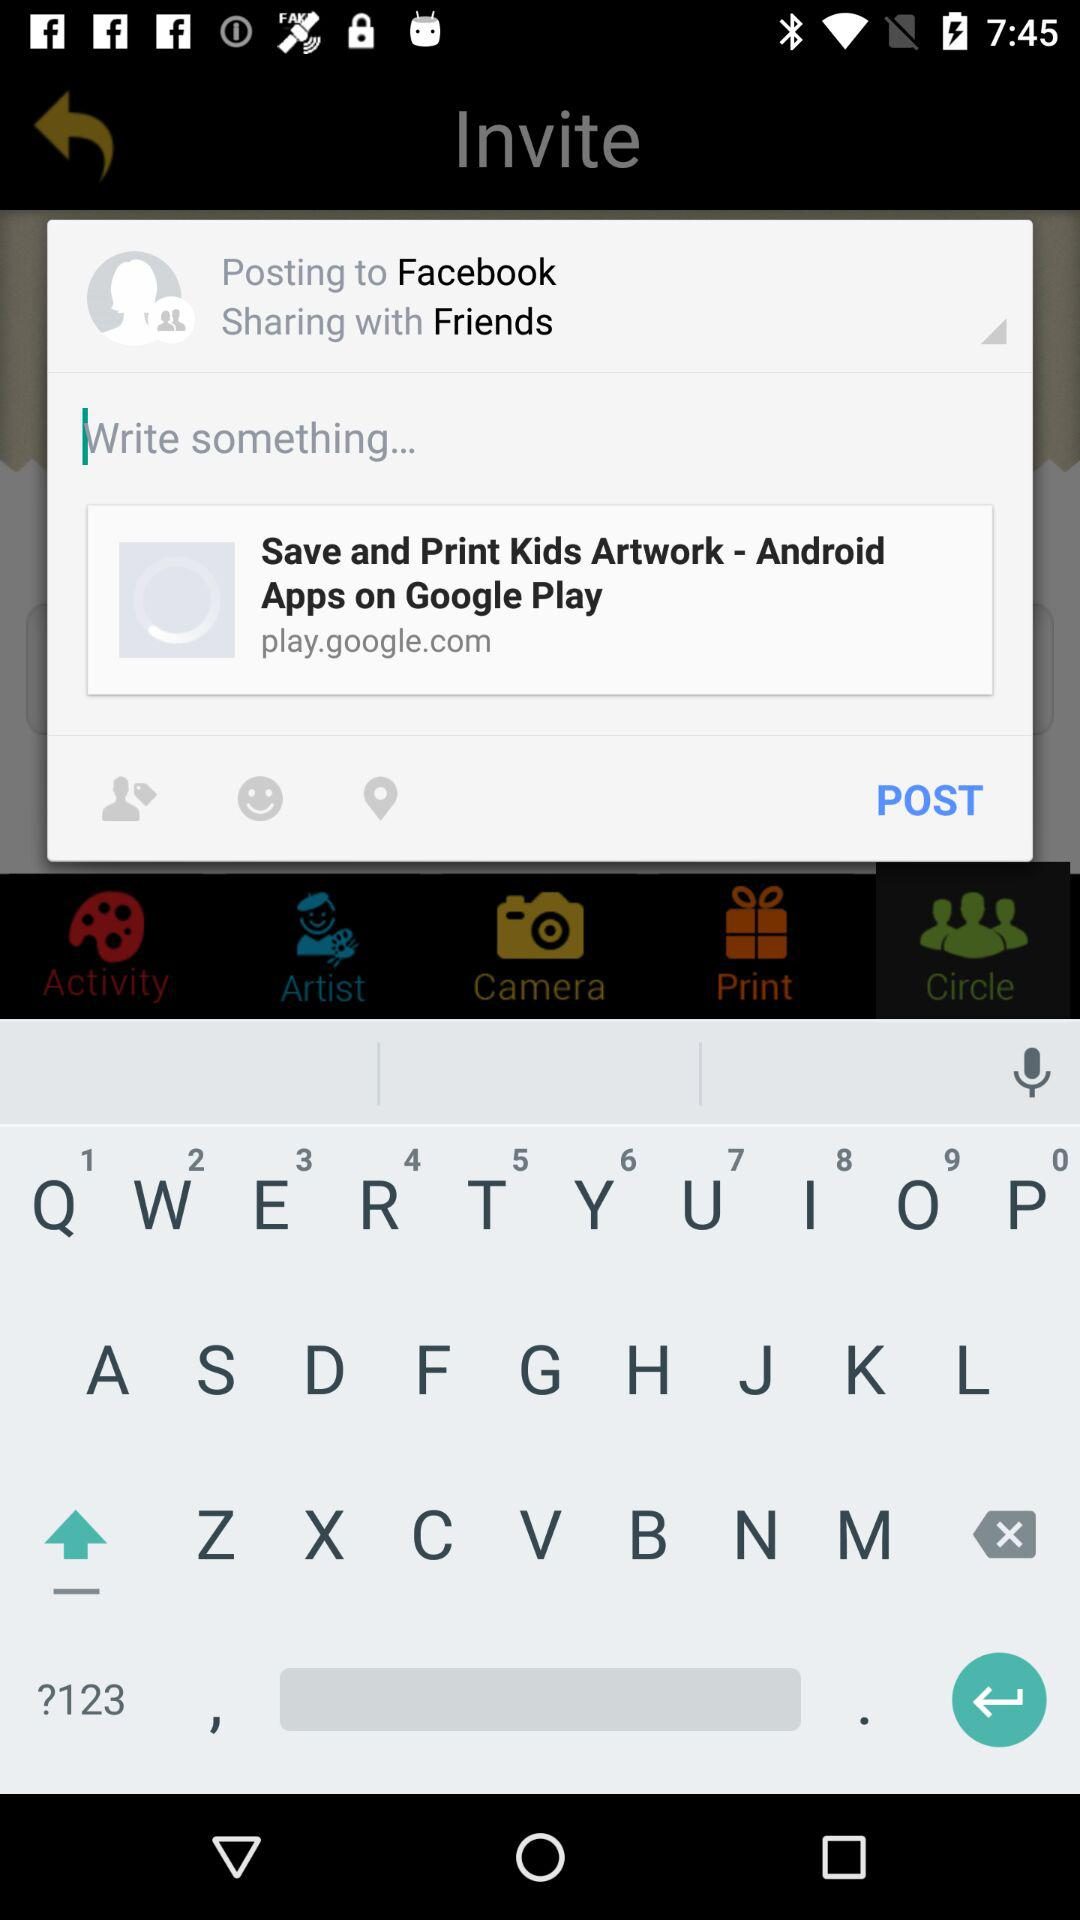What day is it on the selected date? The day is Monday. 